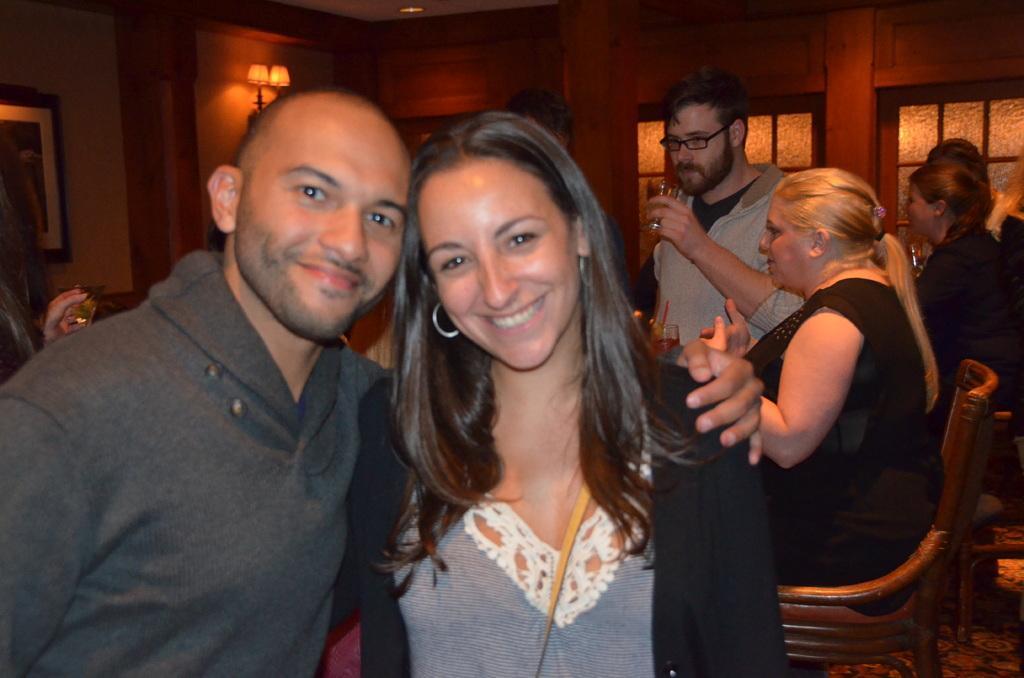Please provide a concise description of this image. In this picture there is a man and a woman who are standing and smiling. There are two women who are sitting in the chair. A person is standing and holding a cup in his hand. There is a lamp unto the top left. A frame is visible on the wall. 